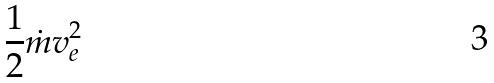<formula> <loc_0><loc_0><loc_500><loc_500>\frac { 1 } { 2 } \dot { m } v _ { e } ^ { 2 }</formula> 